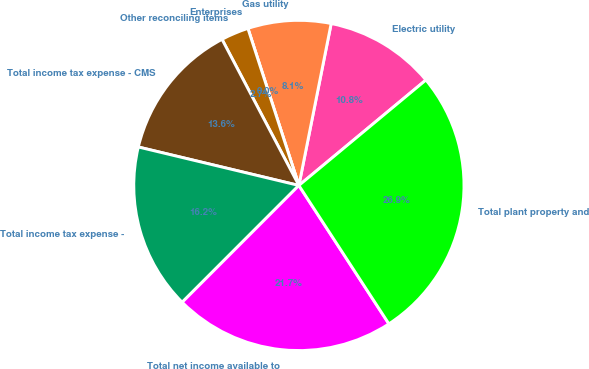<chart> <loc_0><loc_0><loc_500><loc_500><pie_chart><fcel>Electric utility<fcel>Gas utility<fcel>Enterprises<fcel>Other reconciling items<fcel>Total income tax expense - CMS<fcel>Total income tax expense -<fcel>Total net income available to<fcel>Total plant property and<nl><fcel>10.84%<fcel>8.13%<fcel>0.0%<fcel>2.71%<fcel>13.55%<fcel>16.25%<fcel>21.67%<fcel>26.85%<nl></chart> 